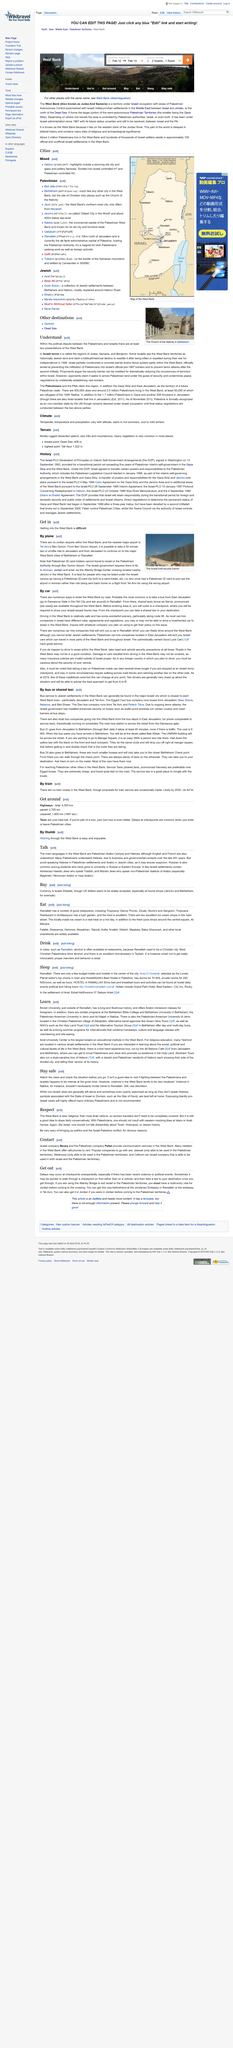Outline some significant characteristics in this image. The Israeli-built security barrier is depicted in the image. There are no civilian airports in the West Bank, and therefore it is not possible to determine the number of such airports that exist in that region. Yes, getting into the West Bank is difficult. 